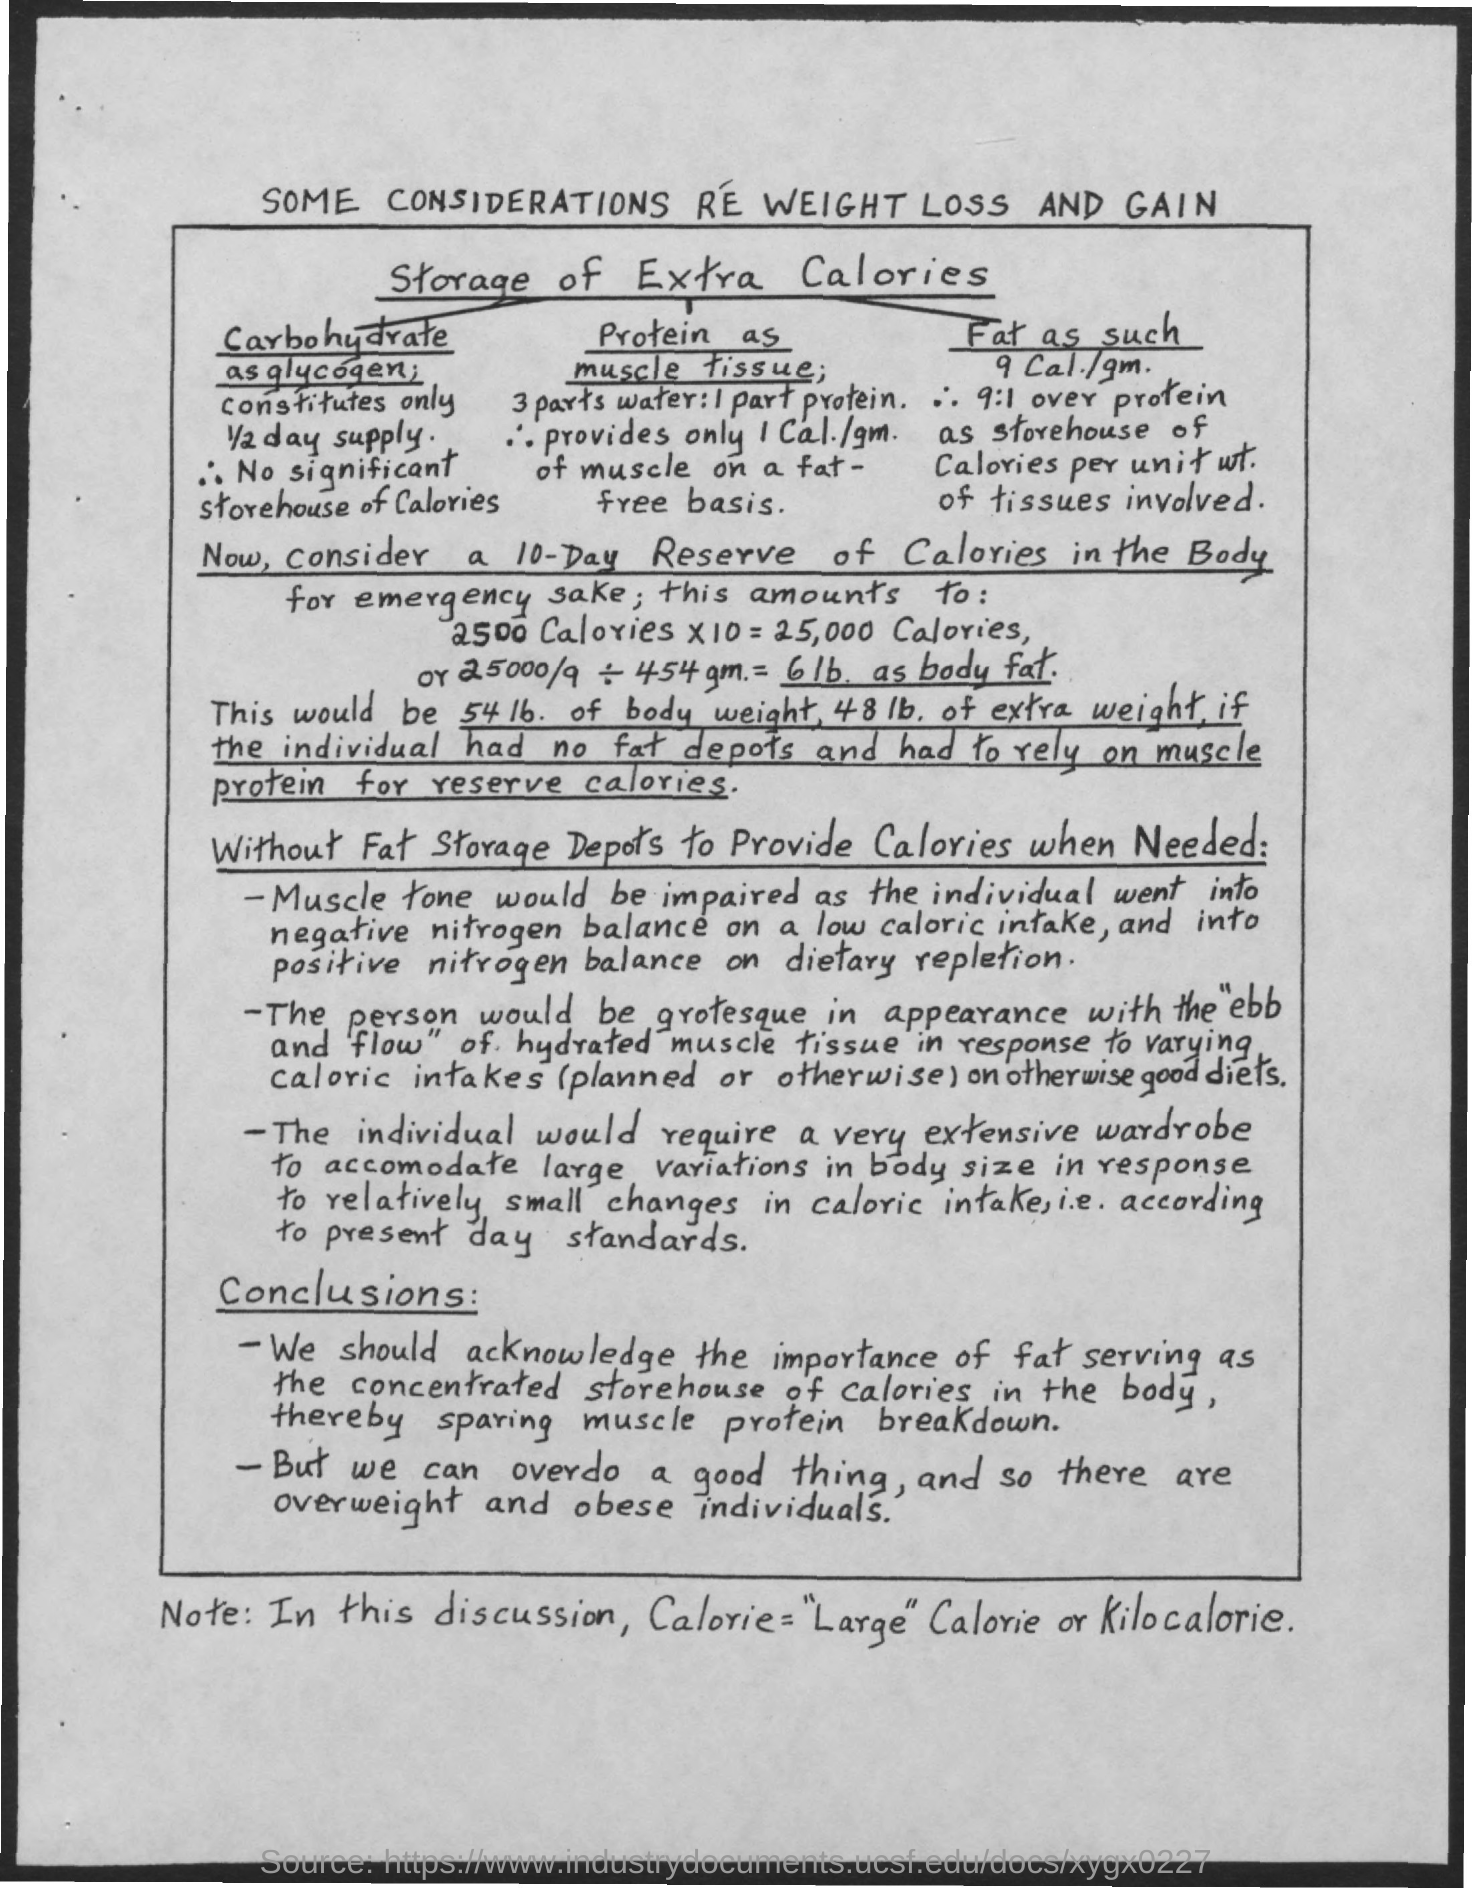Identify some key points in this picture. The document discusses the topic of weight loss and gain, with considerations and thoughts included. Large calories refer to kilocalories. 